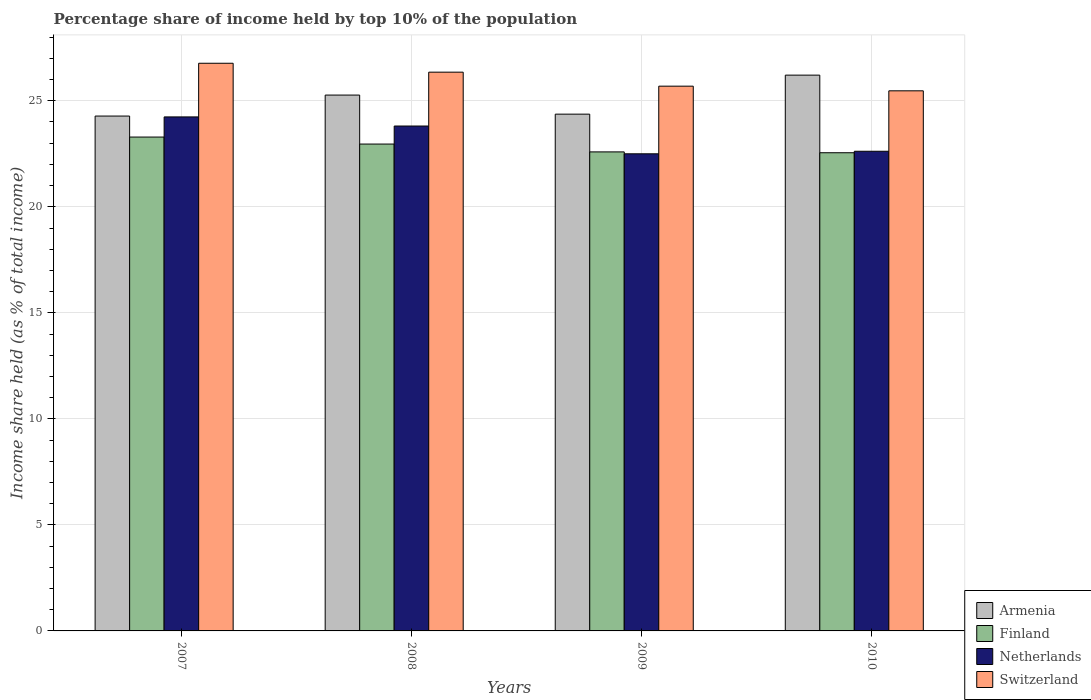How many different coloured bars are there?
Keep it short and to the point. 4. How many groups of bars are there?
Provide a succinct answer. 4. Are the number of bars on each tick of the X-axis equal?
Provide a succinct answer. Yes. How many bars are there on the 2nd tick from the left?
Your answer should be very brief. 4. What is the label of the 1st group of bars from the left?
Ensure brevity in your answer.  2007. What is the percentage share of income held by top 10% of the population in Finland in 2009?
Your response must be concise. 22.59. Across all years, what is the maximum percentage share of income held by top 10% of the population in Netherlands?
Give a very brief answer. 24.24. Across all years, what is the minimum percentage share of income held by top 10% of the population in Switzerland?
Offer a terse response. 25.47. In which year was the percentage share of income held by top 10% of the population in Finland maximum?
Offer a terse response. 2007. In which year was the percentage share of income held by top 10% of the population in Switzerland minimum?
Your response must be concise. 2010. What is the total percentage share of income held by top 10% of the population in Finland in the graph?
Your response must be concise. 91.39. What is the difference between the percentage share of income held by top 10% of the population in Armenia in 2008 and that in 2010?
Provide a succinct answer. -0.94. What is the difference between the percentage share of income held by top 10% of the population in Armenia in 2008 and the percentage share of income held by top 10% of the population in Finland in 2010?
Provide a succinct answer. 2.72. What is the average percentage share of income held by top 10% of the population in Finland per year?
Keep it short and to the point. 22.85. In the year 2010, what is the difference between the percentage share of income held by top 10% of the population in Finland and percentage share of income held by top 10% of the population in Switzerland?
Your answer should be compact. -2.92. What is the ratio of the percentage share of income held by top 10% of the population in Switzerland in 2007 to that in 2009?
Ensure brevity in your answer.  1.04. Is the percentage share of income held by top 10% of the population in Netherlands in 2007 less than that in 2010?
Give a very brief answer. No. What is the difference between the highest and the second highest percentage share of income held by top 10% of the population in Finland?
Provide a short and direct response. 0.33. What is the difference between the highest and the lowest percentage share of income held by top 10% of the population in Netherlands?
Your answer should be very brief. 1.74. Is the sum of the percentage share of income held by top 10% of the population in Armenia in 2009 and 2010 greater than the maximum percentage share of income held by top 10% of the population in Netherlands across all years?
Ensure brevity in your answer.  Yes. What does the 1st bar from the right in 2007 represents?
Make the answer very short. Switzerland. What is the difference between two consecutive major ticks on the Y-axis?
Your answer should be very brief. 5. Does the graph contain grids?
Your answer should be very brief. Yes. How many legend labels are there?
Ensure brevity in your answer.  4. How are the legend labels stacked?
Your response must be concise. Vertical. What is the title of the graph?
Provide a short and direct response. Percentage share of income held by top 10% of the population. Does "Qatar" appear as one of the legend labels in the graph?
Offer a very short reply. No. What is the label or title of the Y-axis?
Provide a succinct answer. Income share held (as % of total income). What is the Income share held (as % of total income) in Armenia in 2007?
Make the answer very short. 24.28. What is the Income share held (as % of total income) in Finland in 2007?
Your answer should be very brief. 23.29. What is the Income share held (as % of total income) of Netherlands in 2007?
Your answer should be very brief. 24.24. What is the Income share held (as % of total income) of Switzerland in 2007?
Offer a very short reply. 26.77. What is the Income share held (as % of total income) in Armenia in 2008?
Give a very brief answer. 25.27. What is the Income share held (as % of total income) in Finland in 2008?
Provide a succinct answer. 22.96. What is the Income share held (as % of total income) in Netherlands in 2008?
Your response must be concise. 23.81. What is the Income share held (as % of total income) in Switzerland in 2008?
Your answer should be very brief. 26.35. What is the Income share held (as % of total income) in Armenia in 2009?
Your response must be concise. 24.37. What is the Income share held (as % of total income) of Finland in 2009?
Your response must be concise. 22.59. What is the Income share held (as % of total income) in Switzerland in 2009?
Keep it short and to the point. 25.69. What is the Income share held (as % of total income) of Armenia in 2010?
Offer a terse response. 26.21. What is the Income share held (as % of total income) in Finland in 2010?
Provide a succinct answer. 22.55. What is the Income share held (as % of total income) in Netherlands in 2010?
Give a very brief answer. 22.62. What is the Income share held (as % of total income) of Switzerland in 2010?
Your response must be concise. 25.47. Across all years, what is the maximum Income share held (as % of total income) in Armenia?
Ensure brevity in your answer.  26.21. Across all years, what is the maximum Income share held (as % of total income) of Finland?
Ensure brevity in your answer.  23.29. Across all years, what is the maximum Income share held (as % of total income) in Netherlands?
Ensure brevity in your answer.  24.24. Across all years, what is the maximum Income share held (as % of total income) of Switzerland?
Your response must be concise. 26.77. Across all years, what is the minimum Income share held (as % of total income) of Armenia?
Offer a very short reply. 24.28. Across all years, what is the minimum Income share held (as % of total income) of Finland?
Give a very brief answer. 22.55. Across all years, what is the minimum Income share held (as % of total income) of Netherlands?
Give a very brief answer. 22.5. Across all years, what is the minimum Income share held (as % of total income) of Switzerland?
Give a very brief answer. 25.47. What is the total Income share held (as % of total income) of Armenia in the graph?
Give a very brief answer. 100.13. What is the total Income share held (as % of total income) of Finland in the graph?
Your answer should be very brief. 91.39. What is the total Income share held (as % of total income) in Netherlands in the graph?
Offer a terse response. 93.17. What is the total Income share held (as % of total income) of Switzerland in the graph?
Offer a terse response. 104.28. What is the difference between the Income share held (as % of total income) in Armenia in 2007 and that in 2008?
Give a very brief answer. -0.99. What is the difference between the Income share held (as % of total income) of Finland in 2007 and that in 2008?
Your answer should be very brief. 0.33. What is the difference between the Income share held (as % of total income) in Netherlands in 2007 and that in 2008?
Your answer should be compact. 0.43. What is the difference between the Income share held (as % of total income) of Switzerland in 2007 and that in 2008?
Give a very brief answer. 0.42. What is the difference between the Income share held (as % of total income) of Armenia in 2007 and that in 2009?
Ensure brevity in your answer.  -0.09. What is the difference between the Income share held (as % of total income) of Finland in 2007 and that in 2009?
Provide a succinct answer. 0.7. What is the difference between the Income share held (as % of total income) in Netherlands in 2007 and that in 2009?
Your answer should be compact. 1.74. What is the difference between the Income share held (as % of total income) of Armenia in 2007 and that in 2010?
Keep it short and to the point. -1.93. What is the difference between the Income share held (as % of total income) in Finland in 2007 and that in 2010?
Offer a very short reply. 0.74. What is the difference between the Income share held (as % of total income) of Netherlands in 2007 and that in 2010?
Offer a terse response. 1.62. What is the difference between the Income share held (as % of total income) of Armenia in 2008 and that in 2009?
Provide a succinct answer. 0.9. What is the difference between the Income share held (as % of total income) of Finland in 2008 and that in 2009?
Keep it short and to the point. 0.37. What is the difference between the Income share held (as % of total income) in Netherlands in 2008 and that in 2009?
Ensure brevity in your answer.  1.31. What is the difference between the Income share held (as % of total income) of Switzerland in 2008 and that in 2009?
Keep it short and to the point. 0.66. What is the difference between the Income share held (as % of total income) of Armenia in 2008 and that in 2010?
Offer a very short reply. -0.94. What is the difference between the Income share held (as % of total income) in Finland in 2008 and that in 2010?
Ensure brevity in your answer.  0.41. What is the difference between the Income share held (as % of total income) in Netherlands in 2008 and that in 2010?
Your answer should be very brief. 1.19. What is the difference between the Income share held (as % of total income) in Armenia in 2009 and that in 2010?
Offer a terse response. -1.84. What is the difference between the Income share held (as % of total income) in Finland in 2009 and that in 2010?
Your answer should be very brief. 0.04. What is the difference between the Income share held (as % of total income) in Netherlands in 2009 and that in 2010?
Offer a very short reply. -0.12. What is the difference between the Income share held (as % of total income) in Switzerland in 2009 and that in 2010?
Provide a succinct answer. 0.22. What is the difference between the Income share held (as % of total income) of Armenia in 2007 and the Income share held (as % of total income) of Finland in 2008?
Give a very brief answer. 1.32. What is the difference between the Income share held (as % of total income) in Armenia in 2007 and the Income share held (as % of total income) in Netherlands in 2008?
Offer a terse response. 0.47. What is the difference between the Income share held (as % of total income) of Armenia in 2007 and the Income share held (as % of total income) of Switzerland in 2008?
Offer a terse response. -2.07. What is the difference between the Income share held (as % of total income) of Finland in 2007 and the Income share held (as % of total income) of Netherlands in 2008?
Keep it short and to the point. -0.52. What is the difference between the Income share held (as % of total income) in Finland in 2007 and the Income share held (as % of total income) in Switzerland in 2008?
Your answer should be very brief. -3.06. What is the difference between the Income share held (as % of total income) of Netherlands in 2007 and the Income share held (as % of total income) of Switzerland in 2008?
Offer a terse response. -2.11. What is the difference between the Income share held (as % of total income) in Armenia in 2007 and the Income share held (as % of total income) in Finland in 2009?
Your answer should be compact. 1.69. What is the difference between the Income share held (as % of total income) in Armenia in 2007 and the Income share held (as % of total income) in Netherlands in 2009?
Provide a succinct answer. 1.78. What is the difference between the Income share held (as % of total income) in Armenia in 2007 and the Income share held (as % of total income) in Switzerland in 2009?
Your answer should be compact. -1.41. What is the difference between the Income share held (as % of total income) of Finland in 2007 and the Income share held (as % of total income) of Netherlands in 2009?
Give a very brief answer. 0.79. What is the difference between the Income share held (as % of total income) of Netherlands in 2007 and the Income share held (as % of total income) of Switzerland in 2009?
Provide a succinct answer. -1.45. What is the difference between the Income share held (as % of total income) of Armenia in 2007 and the Income share held (as % of total income) of Finland in 2010?
Make the answer very short. 1.73. What is the difference between the Income share held (as % of total income) of Armenia in 2007 and the Income share held (as % of total income) of Netherlands in 2010?
Offer a terse response. 1.66. What is the difference between the Income share held (as % of total income) of Armenia in 2007 and the Income share held (as % of total income) of Switzerland in 2010?
Provide a succinct answer. -1.19. What is the difference between the Income share held (as % of total income) in Finland in 2007 and the Income share held (as % of total income) in Netherlands in 2010?
Your answer should be compact. 0.67. What is the difference between the Income share held (as % of total income) in Finland in 2007 and the Income share held (as % of total income) in Switzerland in 2010?
Ensure brevity in your answer.  -2.18. What is the difference between the Income share held (as % of total income) of Netherlands in 2007 and the Income share held (as % of total income) of Switzerland in 2010?
Give a very brief answer. -1.23. What is the difference between the Income share held (as % of total income) in Armenia in 2008 and the Income share held (as % of total income) in Finland in 2009?
Your response must be concise. 2.68. What is the difference between the Income share held (as % of total income) in Armenia in 2008 and the Income share held (as % of total income) in Netherlands in 2009?
Provide a short and direct response. 2.77. What is the difference between the Income share held (as % of total income) of Armenia in 2008 and the Income share held (as % of total income) of Switzerland in 2009?
Ensure brevity in your answer.  -0.42. What is the difference between the Income share held (as % of total income) in Finland in 2008 and the Income share held (as % of total income) in Netherlands in 2009?
Provide a short and direct response. 0.46. What is the difference between the Income share held (as % of total income) in Finland in 2008 and the Income share held (as % of total income) in Switzerland in 2009?
Your answer should be compact. -2.73. What is the difference between the Income share held (as % of total income) of Netherlands in 2008 and the Income share held (as % of total income) of Switzerland in 2009?
Make the answer very short. -1.88. What is the difference between the Income share held (as % of total income) of Armenia in 2008 and the Income share held (as % of total income) of Finland in 2010?
Your response must be concise. 2.72. What is the difference between the Income share held (as % of total income) in Armenia in 2008 and the Income share held (as % of total income) in Netherlands in 2010?
Offer a very short reply. 2.65. What is the difference between the Income share held (as % of total income) in Finland in 2008 and the Income share held (as % of total income) in Netherlands in 2010?
Keep it short and to the point. 0.34. What is the difference between the Income share held (as % of total income) in Finland in 2008 and the Income share held (as % of total income) in Switzerland in 2010?
Give a very brief answer. -2.51. What is the difference between the Income share held (as % of total income) in Netherlands in 2008 and the Income share held (as % of total income) in Switzerland in 2010?
Your answer should be very brief. -1.66. What is the difference between the Income share held (as % of total income) of Armenia in 2009 and the Income share held (as % of total income) of Finland in 2010?
Your answer should be compact. 1.82. What is the difference between the Income share held (as % of total income) of Armenia in 2009 and the Income share held (as % of total income) of Switzerland in 2010?
Ensure brevity in your answer.  -1.1. What is the difference between the Income share held (as % of total income) in Finland in 2009 and the Income share held (as % of total income) in Netherlands in 2010?
Ensure brevity in your answer.  -0.03. What is the difference between the Income share held (as % of total income) in Finland in 2009 and the Income share held (as % of total income) in Switzerland in 2010?
Provide a short and direct response. -2.88. What is the difference between the Income share held (as % of total income) in Netherlands in 2009 and the Income share held (as % of total income) in Switzerland in 2010?
Your answer should be very brief. -2.97. What is the average Income share held (as % of total income) of Armenia per year?
Ensure brevity in your answer.  25.03. What is the average Income share held (as % of total income) in Finland per year?
Provide a succinct answer. 22.85. What is the average Income share held (as % of total income) of Netherlands per year?
Give a very brief answer. 23.29. What is the average Income share held (as % of total income) of Switzerland per year?
Your answer should be compact. 26.07. In the year 2007, what is the difference between the Income share held (as % of total income) of Armenia and Income share held (as % of total income) of Netherlands?
Provide a succinct answer. 0.04. In the year 2007, what is the difference between the Income share held (as % of total income) in Armenia and Income share held (as % of total income) in Switzerland?
Provide a succinct answer. -2.49. In the year 2007, what is the difference between the Income share held (as % of total income) of Finland and Income share held (as % of total income) of Netherlands?
Offer a terse response. -0.95. In the year 2007, what is the difference between the Income share held (as % of total income) in Finland and Income share held (as % of total income) in Switzerland?
Offer a very short reply. -3.48. In the year 2007, what is the difference between the Income share held (as % of total income) of Netherlands and Income share held (as % of total income) of Switzerland?
Provide a short and direct response. -2.53. In the year 2008, what is the difference between the Income share held (as % of total income) of Armenia and Income share held (as % of total income) of Finland?
Your answer should be compact. 2.31. In the year 2008, what is the difference between the Income share held (as % of total income) in Armenia and Income share held (as % of total income) in Netherlands?
Ensure brevity in your answer.  1.46. In the year 2008, what is the difference between the Income share held (as % of total income) in Armenia and Income share held (as % of total income) in Switzerland?
Your response must be concise. -1.08. In the year 2008, what is the difference between the Income share held (as % of total income) in Finland and Income share held (as % of total income) in Netherlands?
Your answer should be compact. -0.85. In the year 2008, what is the difference between the Income share held (as % of total income) in Finland and Income share held (as % of total income) in Switzerland?
Your answer should be compact. -3.39. In the year 2008, what is the difference between the Income share held (as % of total income) in Netherlands and Income share held (as % of total income) in Switzerland?
Provide a short and direct response. -2.54. In the year 2009, what is the difference between the Income share held (as % of total income) of Armenia and Income share held (as % of total income) of Finland?
Give a very brief answer. 1.78. In the year 2009, what is the difference between the Income share held (as % of total income) of Armenia and Income share held (as % of total income) of Netherlands?
Give a very brief answer. 1.87. In the year 2009, what is the difference between the Income share held (as % of total income) of Armenia and Income share held (as % of total income) of Switzerland?
Make the answer very short. -1.32. In the year 2009, what is the difference between the Income share held (as % of total income) in Finland and Income share held (as % of total income) in Netherlands?
Give a very brief answer. 0.09. In the year 2009, what is the difference between the Income share held (as % of total income) in Finland and Income share held (as % of total income) in Switzerland?
Your response must be concise. -3.1. In the year 2009, what is the difference between the Income share held (as % of total income) in Netherlands and Income share held (as % of total income) in Switzerland?
Offer a terse response. -3.19. In the year 2010, what is the difference between the Income share held (as % of total income) of Armenia and Income share held (as % of total income) of Finland?
Your answer should be very brief. 3.66. In the year 2010, what is the difference between the Income share held (as % of total income) of Armenia and Income share held (as % of total income) of Netherlands?
Make the answer very short. 3.59. In the year 2010, what is the difference between the Income share held (as % of total income) in Armenia and Income share held (as % of total income) in Switzerland?
Your answer should be very brief. 0.74. In the year 2010, what is the difference between the Income share held (as % of total income) of Finland and Income share held (as % of total income) of Netherlands?
Give a very brief answer. -0.07. In the year 2010, what is the difference between the Income share held (as % of total income) in Finland and Income share held (as % of total income) in Switzerland?
Make the answer very short. -2.92. In the year 2010, what is the difference between the Income share held (as % of total income) in Netherlands and Income share held (as % of total income) in Switzerland?
Provide a succinct answer. -2.85. What is the ratio of the Income share held (as % of total income) of Armenia in 2007 to that in 2008?
Your response must be concise. 0.96. What is the ratio of the Income share held (as % of total income) in Finland in 2007 to that in 2008?
Your answer should be compact. 1.01. What is the ratio of the Income share held (as % of total income) in Netherlands in 2007 to that in 2008?
Make the answer very short. 1.02. What is the ratio of the Income share held (as % of total income) in Switzerland in 2007 to that in 2008?
Provide a short and direct response. 1.02. What is the ratio of the Income share held (as % of total income) in Finland in 2007 to that in 2009?
Your answer should be compact. 1.03. What is the ratio of the Income share held (as % of total income) of Netherlands in 2007 to that in 2009?
Give a very brief answer. 1.08. What is the ratio of the Income share held (as % of total income) in Switzerland in 2007 to that in 2009?
Provide a succinct answer. 1.04. What is the ratio of the Income share held (as % of total income) of Armenia in 2007 to that in 2010?
Offer a terse response. 0.93. What is the ratio of the Income share held (as % of total income) in Finland in 2007 to that in 2010?
Your answer should be very brief. 1.03. What is the ratio of the Income share held (as % of total income) in Netherlands in 2007 to that in 2010?
Make the answer very short. 1.07. What is the ratio of the Income share held (as % of total income) of Switzerland in 2007 to that in 2010?
Offer a terse response. 1.05. What is the ratio of the Income share held (as % of total income) of Armenia in 2008 to that in 2009?
Your answer should be compact. 1.04. What is the ratio of the Income share held (as % of total income) of Finland in 2008 to that in 2009?
Make the answer very short. 1.02. What is the ratio of the Income share held (as % of total income) of Netherlands in 2008 to that in 2009?
Your answer should be compact. 1.06. What is the ratio of the Income share held (as % of total income) of Switzerland in 2008 to that in 2009?
Your response must be concise. 1.03. What is the ratio of the Income share held (as % of total income) of Armenia in 2008 to that in 2010?
Make the answer very short. 0.96. What is the ratio of the Income share held (as % of total income) of Finland in 2008 to that in 2010?
Keep it short and to the point. 1.02. What is the ratio of the Income share held (as % of total income) in Netherlands in 2008 to that in 2010?
Provide a short and direct response. 1.05. What is the ratio of the Income share held (as % of total income) in Switzerland in 2008 to that in 2010?
Your answer should be compact. 1.03. What is the ratio of the Income share held (as % of total income) in Armenia in 2009 to that in 2010?
Ensure brevity in your answer.  0.93. What is the ratio of the Income share held (as % of total income) of Finland in 2009 to that in 2010?
Offer a terse response. 1. What is the ratio of the Income share held (as % of total income) of Switzerland in 2009 to that in 2010?
Give a very brief answer. 1.01. What is the difference between the highest and the second highest Income share held (as % of total income) in Finland?
Keep it short and to the point. 0.33. What is the difference between the highest and the second highest Income share held (as % of total income) in Netherlands?
Offer a terse response. 0.43. What is the difference between the highest and the second highest Income share held (as % of total income) in Switzerland?
Make the answer very short. 0.42. What is the difference between the highest and the lowest Income share held (as % of total income) of Armenia?
Your answer should be very brief. 1.93. What is the difference between the highest and the lowest Income share held (as % of total income) in Finland?
Make the answer very short. 0.74. What is the difference between the highest and the lowest Income share held (as % of total income) of Netherlands?
Give a very brief answer. 1.74. 